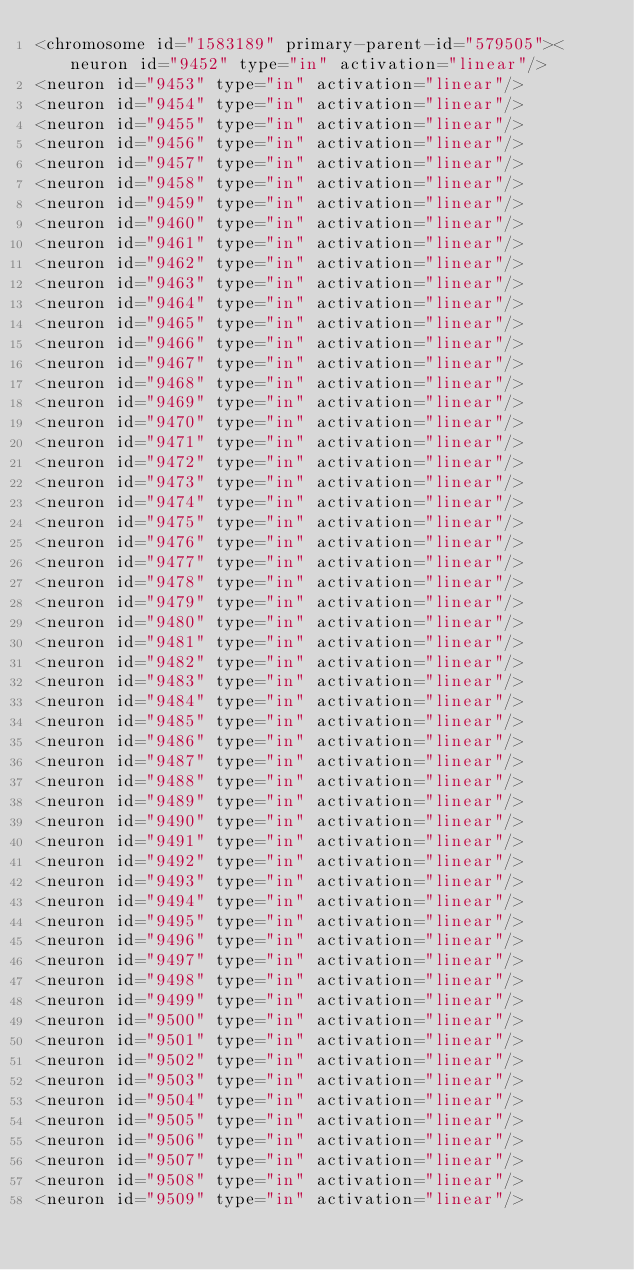Convert code to text. <code><loc_0><loc_0><loc_500><loc_500><_XML_><chromosome id="1583189" primary-parent-id="579505"><neuron id="9452" type="in" activation="linear"/>
<neuron id="9453" type="in" activation="linear"/>
<neuron id="9454" type="in" activation="linear"/>
<neuron id="9455" type="in" activation="linear"/>
<neuron id="9456" type="in" activation="linear"/>
<neuron id="9457" type="in" activation="linear"/>
<neuron id="9458" type="in" activation="linear"/>
<neuron id="9459" type="in" activation="linear"/>
<neuron id="9460" type="in" activation="linear"/>
<neuron id="9461" type="in" activation="linear"/>
<neuron id="9462" type="in" activation="linear"/>
<neuron id="9463" type="in" activation="linear"/>
<neuron id="9464" type="in" activation="linear"/>
<neuron id="9465" type="in" activation="linear"/>
<neuron id="9466" type="in" activation="linear"/>
<neuron id="9467" type="in" activation="linear"/>
<neuron id="9468" type="in" activation="linear"/>
<neuron id="9469" type="in" activation="linear"/>
<neuron id="9470" type="in" activation="linear"/>
<neuron id="9471" type="in" activation="linear"/>
<neuron id="9472" type="in" activation="linear"/>
<neuron id="9473" type="in" activation="linear"/>
<neuron id="9474" type="in" activation="linear"/>
<neuron id="9475" type="in" activation="linear"/>
<neuron id="9476" type="in" activation="linear"/>
<neuron id="9477" type="in" activation="linear"/>
<neuron id="9478" type="in" activation="linear"/>
<neuron id="9479" type="in" activation="linear"/>
<neuron id="9480" type="in" activation="linear"/>
<neuron id="9481" type="in" activation="linear"/>
<neuron id="9482" type="in" activation="linear"/>
<neuron id="9483" type="in" activation="linear"/>
<neuron id="9484" type="in" activation="linear"/>
<neuron id="9485" type="in" activation="linear"/>
<neuron id="9486" type="in" activation="linear"/>
<neuron id="9487" type="in" activation="linear"/>
<neuron id="9488" type="in" activation="linear"/>
<neuron id="9489" type="in" activation="linear"/>
<neuron id="9490" type="in" activation="linear"/>
<neuron id="9491" type="in" activation="linear"/>
<neuron id="9492" type="in" activation="linear"/>
<neuron id="9493" type="in" activation="linear"/>
<neuron id="9494" type="in" activation="linear"/>
<neuron id="9495" type="in" activation="linear"/>
<neuron id="9496" type="in" activation="linear"/>
<neuron id="9497" type="in" activation="linear"/>
<neuron id="9498" type="in" activation="linear"/>
<neuron id="9499" type="in" activation="linear"/>
<neuron id="9500" type="in" activation="linear"/>
<neuron id="9501" type="in" activation="linear"/>
<neuron id="9502" type="in" activation="linear"/>
<neuron id="9503" type="in" activation="linear"/>
<neuron id="9504" type="in" activation="linear"/>
<neuron id="9505" type="in" activation="linear"/>
<neuron id="9506" type="in" activation="linear"/>
<neuron id="9507" type="in" activation="linear"/>
<neuron id="9508" type="in" activation="linear"/>
<neuron id="9509" type="in" activation="linear"/></code> 